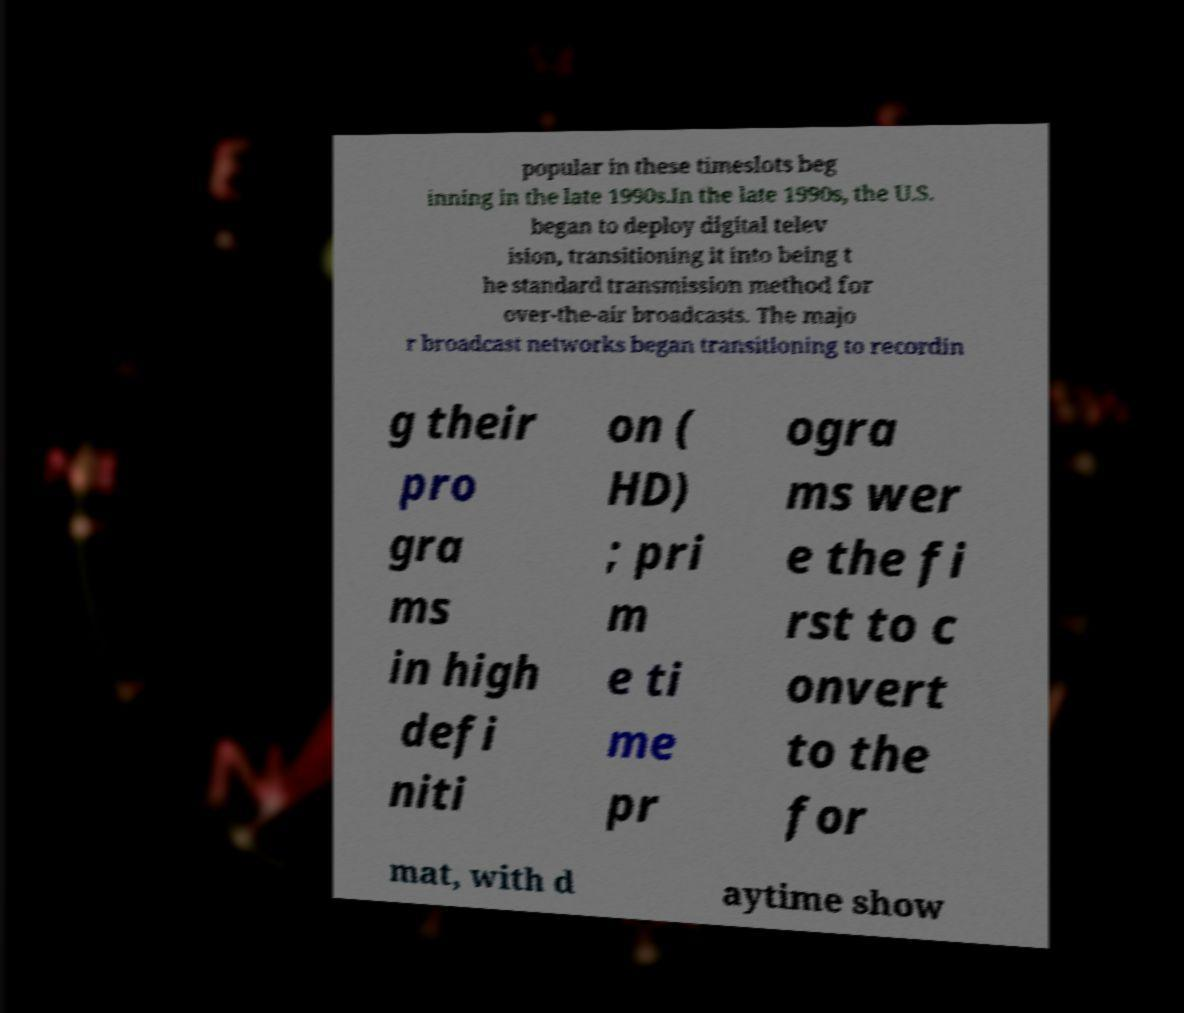Can you read and provide the text displayed in the image?This photo seems to have some interesting text. Can you extract and type it out for me? popular in these timeslots beg inning in the late 1990s.In the late 1990s, the U.S. began to deploy digital telev ision, transitioning it into being t he standard transmission method for over-the-air broadcasts. The majo r broadcast networks began transitioning to recordin g their pro gra ms in high defi niti on ( HD) ; pri m e ti me pr ogra ms wer e the fi rst to c onvert to the for mat, with d aytime show 